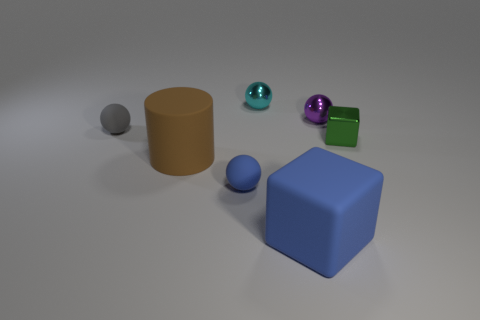Subtract all tiny gray rubber spheres. How many spheres are left? 3 Add 1 cyan spheres. How many objects exist? 8 Subtract all purple balls. How many balls are left? 3 Subtract 2 cubes. How many cubes are left? 0 Add 3 blocks. How many blocks are left? 5 Add 5 big matte objects. How many big matte objects exist? 7 Subtract 0 red cubes. How many objects are left? 7 Subtract all cylinders. How many objects are left? 6 Subtract all purple cubes. Subtract all brown cylinders. How many cubes are left? 2 Subtract all big cylinders. Subtract all tiny gray spheres. How many objects are left? 5 